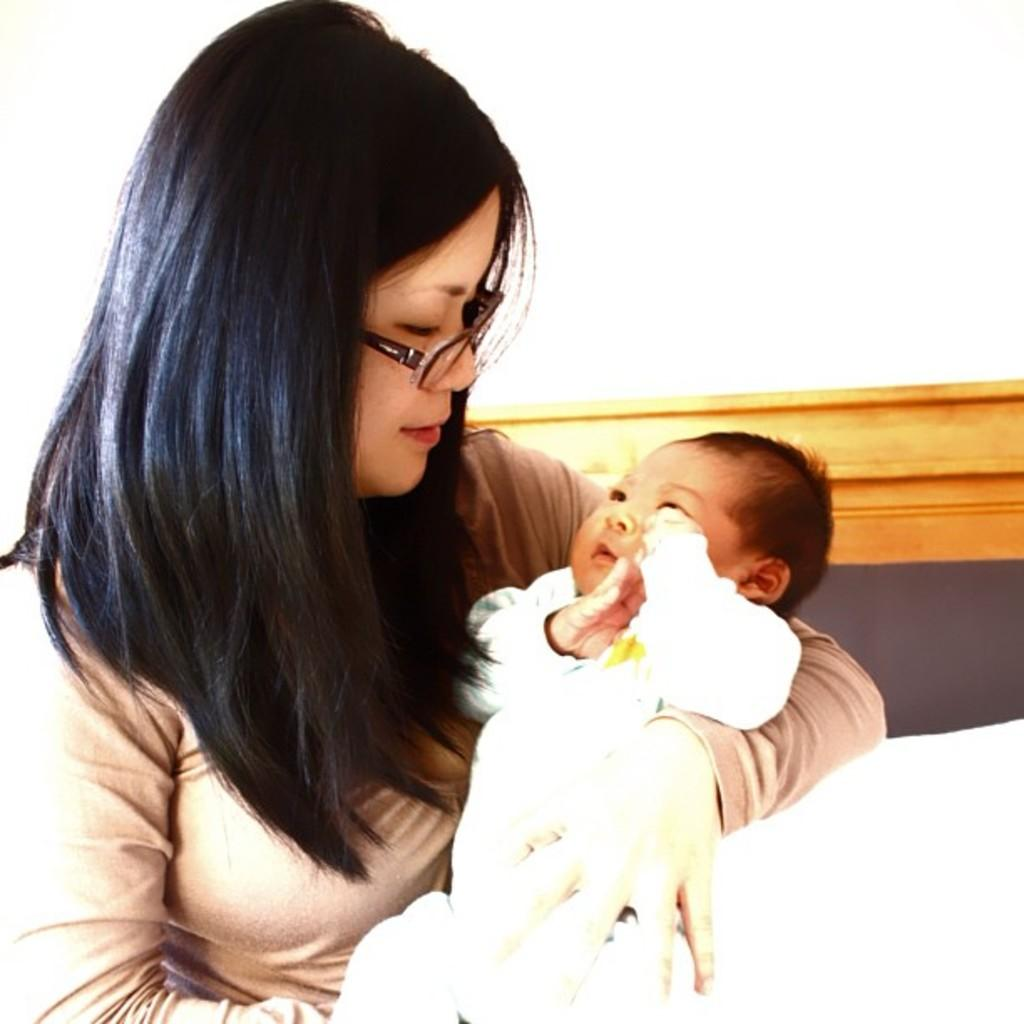What is the woman doing in the image? The woman is carrying a baby in the image. What can be seen in the background of the image? There is a wooden object and a white surface in the background of the image. What type of flower is growing on the wooden object in the image? There is no flower present on the wooden object in the image. 